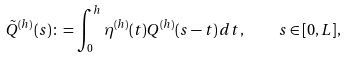Convert formula to latex. <formula><loc_0><loc_0><loc_500><loc_500>\tilde { Q } ^ { ( h ) } ( s ) \colon = \int _ { 0 } ^ { h } \eta ^ { ( h ) } ( t ) Q ^ { ( h ) } ( s - t ) \, d t , \quad s \in [ 0 , L ] ,</formula> 